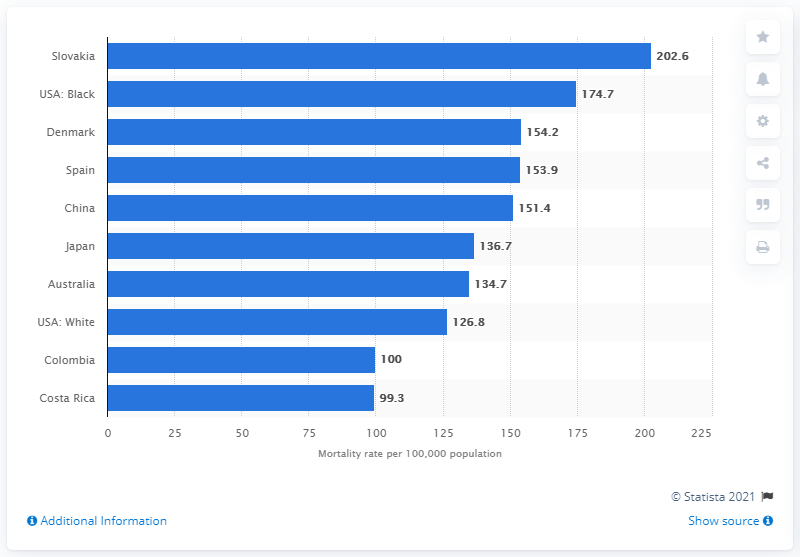List a handful of essential elements in this visual. Slovakia had one of the highest mortality rates worldwide. 